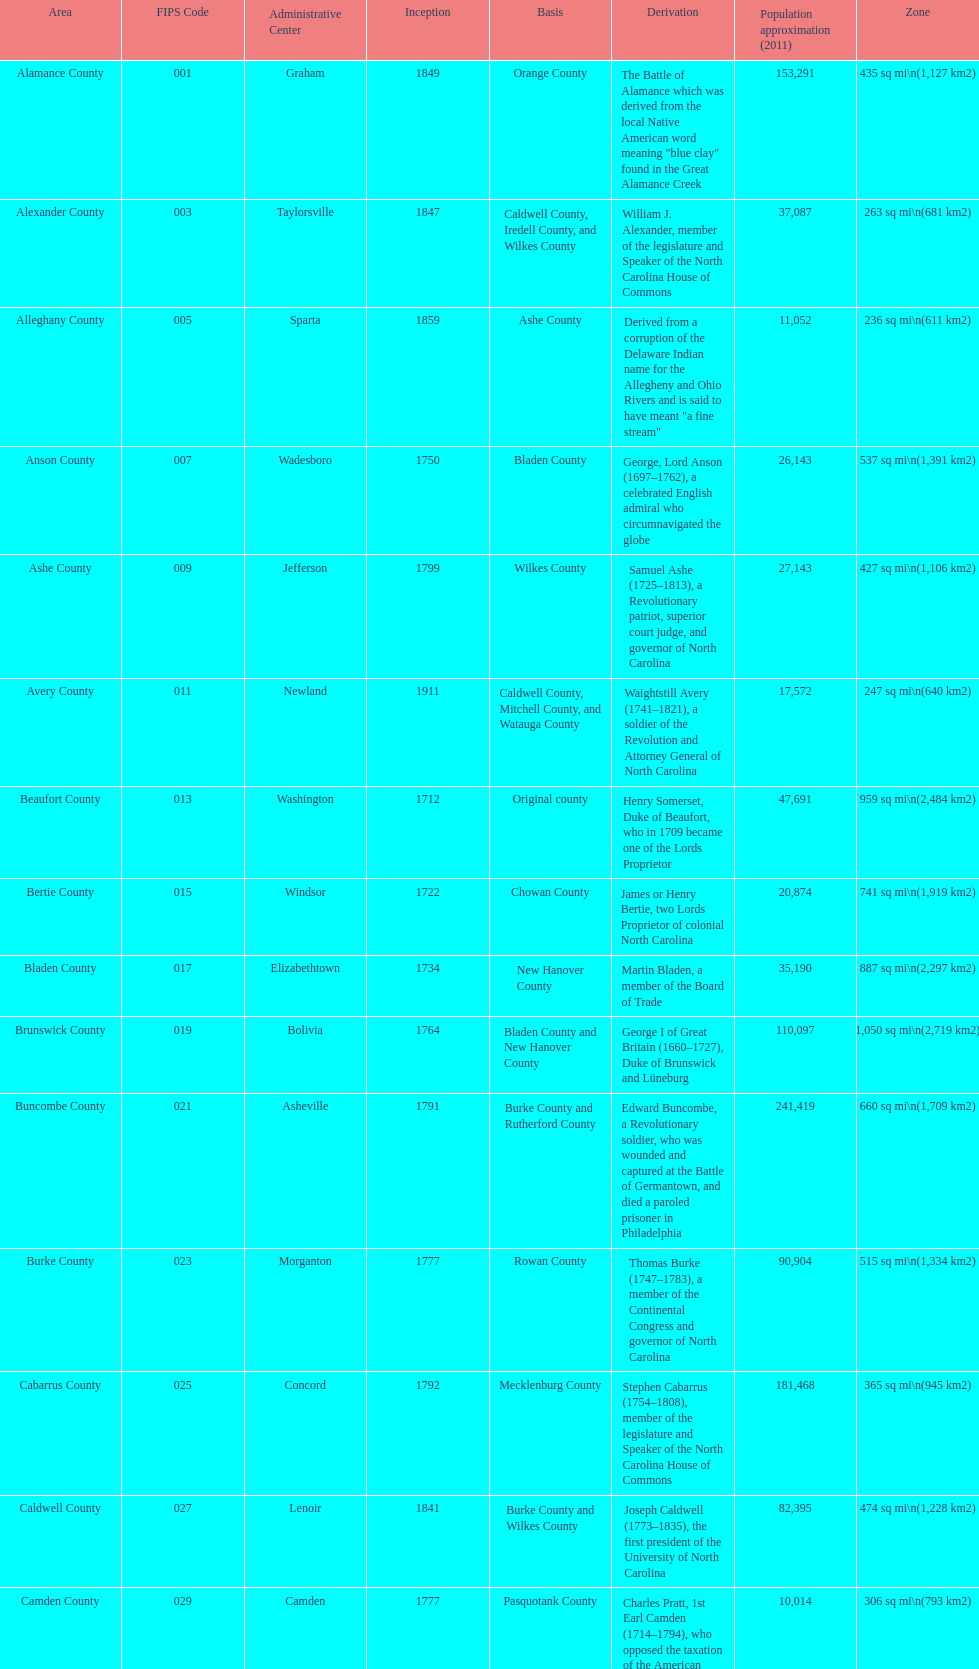Which county has a higher population, alamance or alexander? Alamance County. 